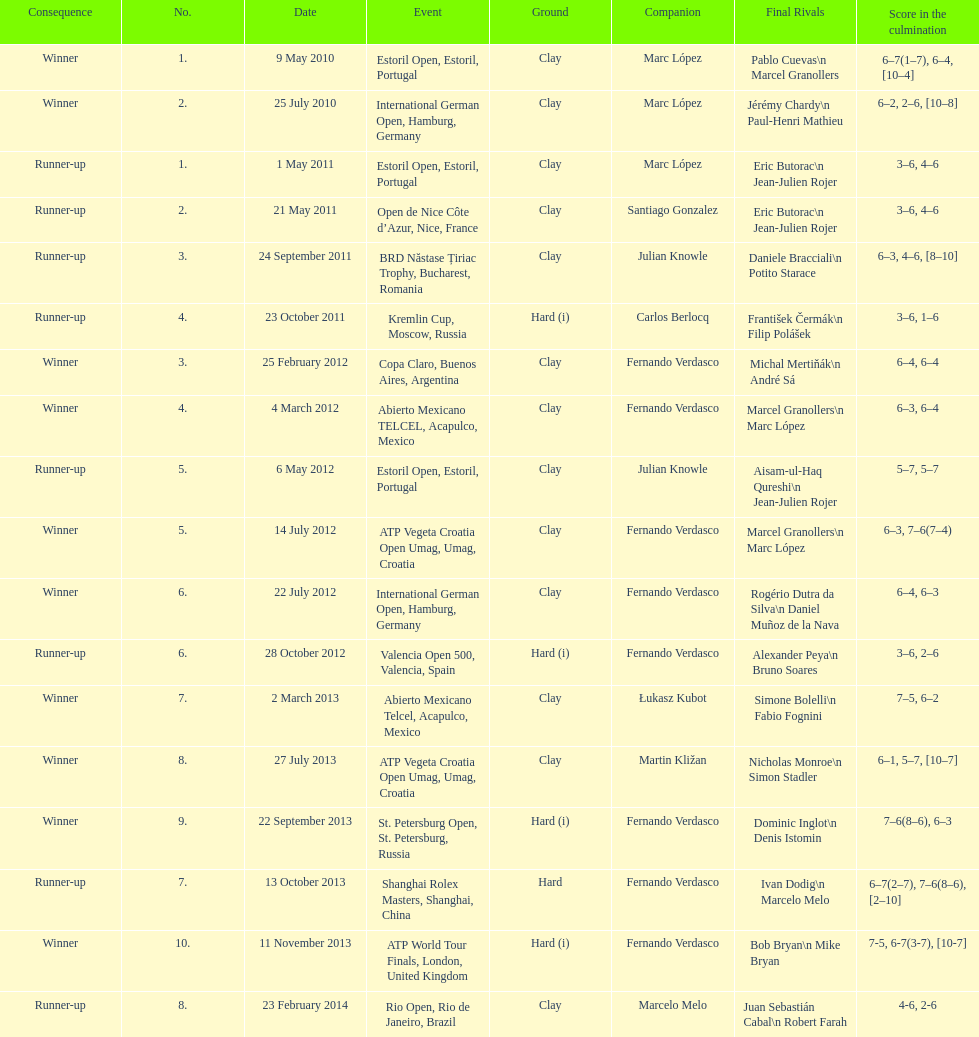Who was this player's next partner after playing with marc lopez in may 2011? Santiago Gonzalez. 